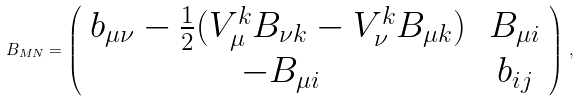<formula> <loc_0><loc_0><loc_500><loc_500>B _ { M N } = \left ( \begin{array} { c c } b _ { \mu \nu } - \frac { 1 } { 2 } ( V ^ { k } _ { \mu } B _ { \nu k } - V ^ { k } _ { \nu } B _ { \mu k } ) \, & B _ { \mu i } \\ - B _ { \mu i } & b _ { i j } \end{array} \right ) \, ,</formula> 